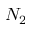<formula> <loc_0><loc_0><loc_500><loc_500>N _ { 2 }</formula> 